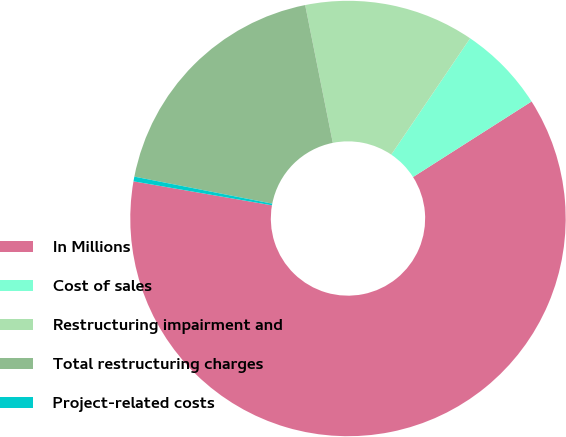Convert chart to OTSL. <chart><loc_0><loc_0><loc_500><loc_500><pie_chart><fcel>In Millions<fcel>Cost of sales<fcel>Restructuring impairment and<fcel>Total restructuring charges<fcel>Project-related costs<nl><fcel>61.77%<fcel>6.49%<fcel>12.63%<fcel>18.77%<fcel>0.35%<nl></chart> 